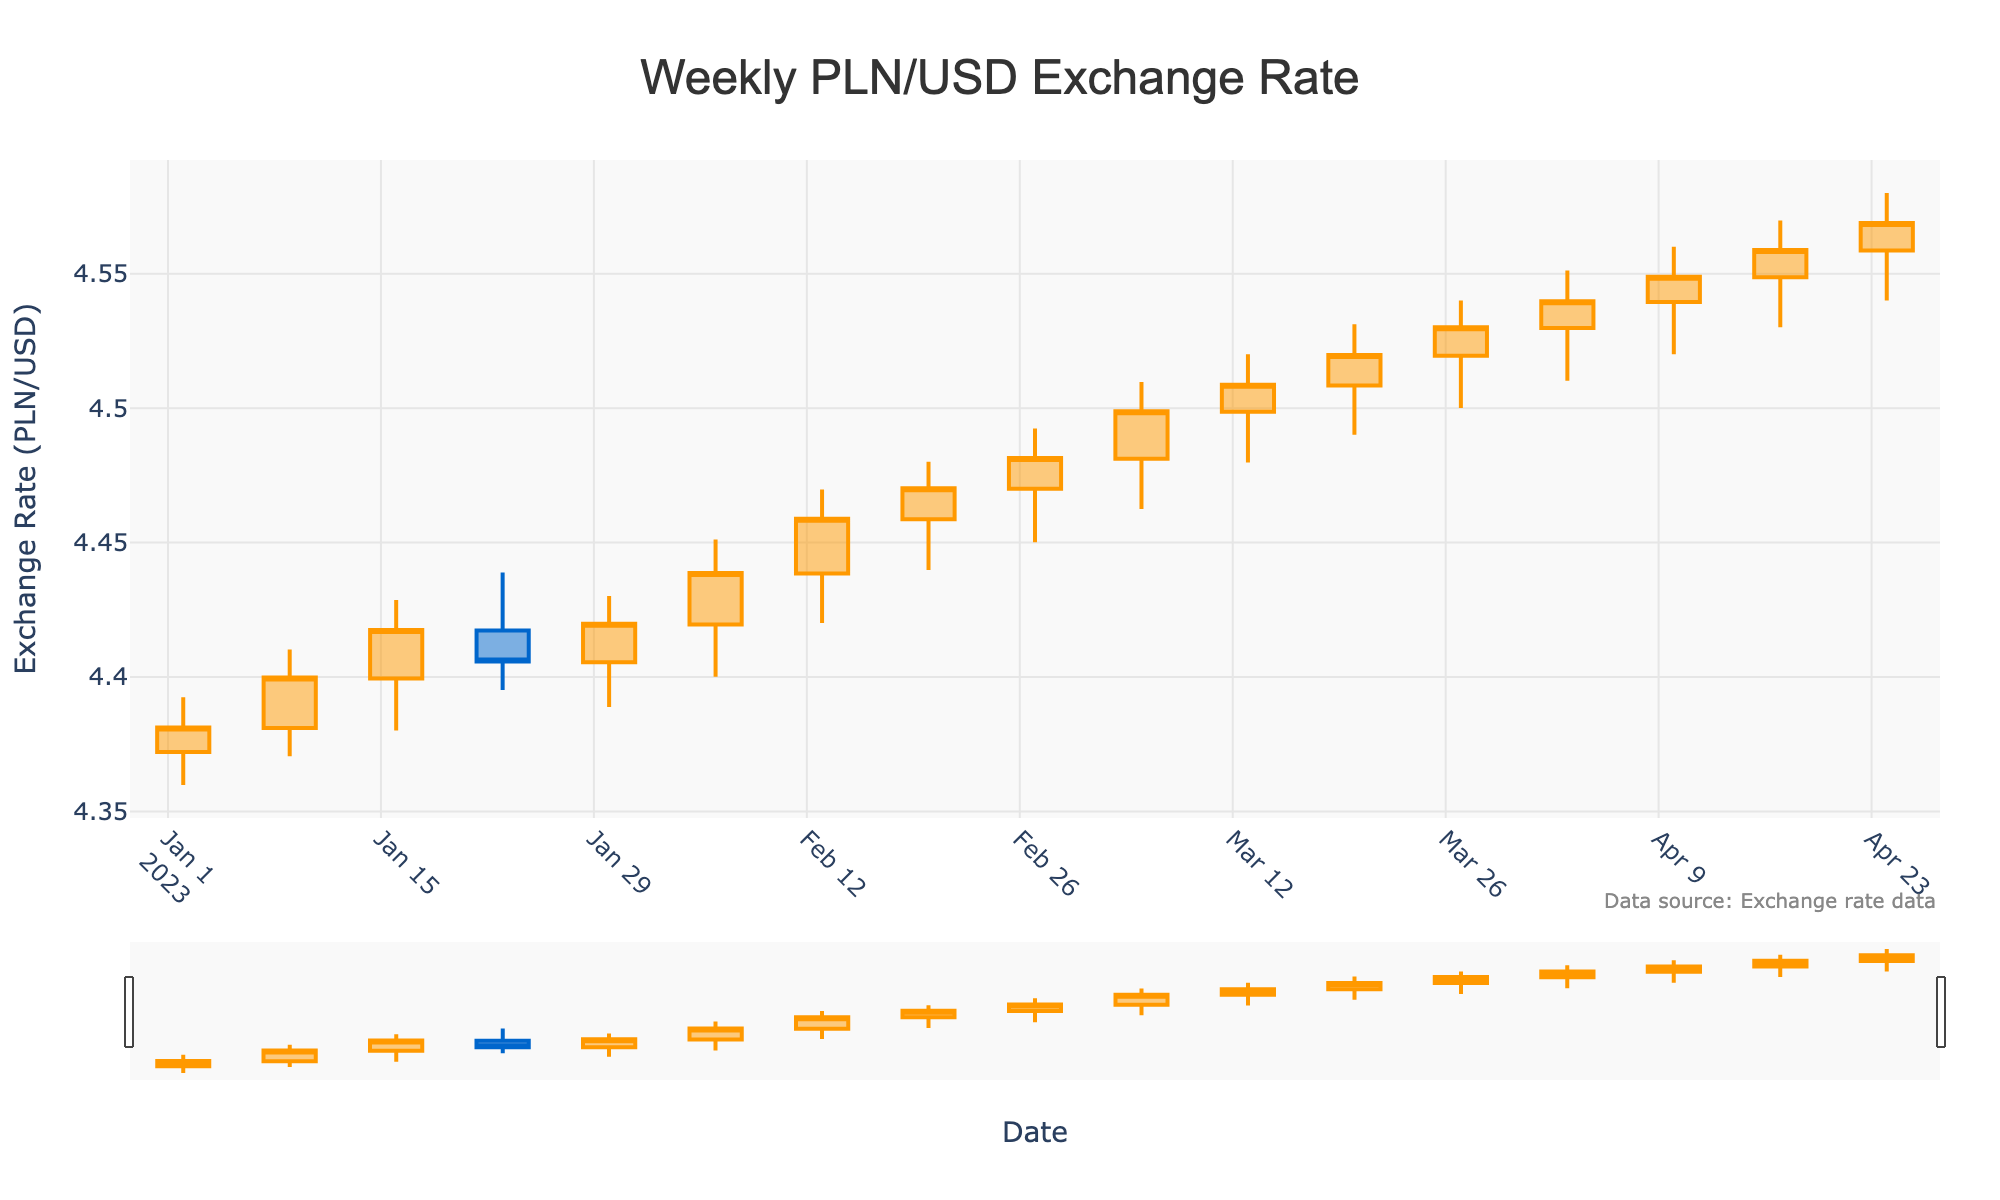What is the title of the chart? The title of the chart is prominently displayed at the top. It reads "Weekly PLN/USD Exchange Rate".
Answer: Weekly PLN/USD Exchange Rate How many weeks of data are displayed in the chart? By counting the number of candlestick bars (one per week), we can determine that there are 16 weeks of data represented in the chart.
Answer: 16 What is the color of the increasing (bullish) candlesticks? The color of the candlesticks that represent an increase in exchange rate (bullish) is orange.
Answer: Orange What period had the highest weekly closing exchange rate? By examining the closing prices at the top of the candlesticks, the week ending on 2023-04-24 had the highest closing exchange rate of 4.5689.
Answer: 2023-04-24 What was the lowest low value throughout the displayed period? The lowest low value can be found by inspecting the bottom tips of the candlesticks. The lowest observed exchange rate during this period was 4.3598 on the week ending 2023-01-02.
Answer: 4.3598 Which week had the highest high value and what was it? By identifying the peak values at the tops of the candlesticks, the week ending on 2023-04-24 had the highest high value of 4.5801.
Answer: 2023-04-24 What was the closing exchange rate on 2023-02-20? By locating the specific candlestick for the week ending on 2023-02-20, we see that the closing price was 4.4702.
Answer: 4.4702 What is the average opening exchange rate over the displayed period? Sum all the opening exchange rates and divide by the total number of weeks. The average opening rate is (4.3721 + 4.3810 + 4.3995 + 4.4173 + 4.4055 + 4.4195 + 4.4385 + 4.4587 + 4.4700 + 4.4812 + 4.4987 + 4.5085 + 4.5195 + 4.5298 + 4.5487 + 4.5587)/(16) = 70.4092/16 = 4.4006.
Answer: 4.4006 Did the exchange rate trend upwards or downwards overall during the displayed year? By comparing the first and last closing prices, the PLN/USD rate starts at 4.3812 and ends at 4.5689, indicating an overall upward trend.
Answer: Upwards Which week showed the largest difference between the high and low values? Calculate the difference between the high and low values for each week and find the maximum. The largest difference is in the week ending on 2023-04-24 with a high of 4.5801 and a low of 4.5401, giving a difference of 4.5801 - 4.5401 = 0.04.
Answer: 2023-04-24, difference = 0.04 